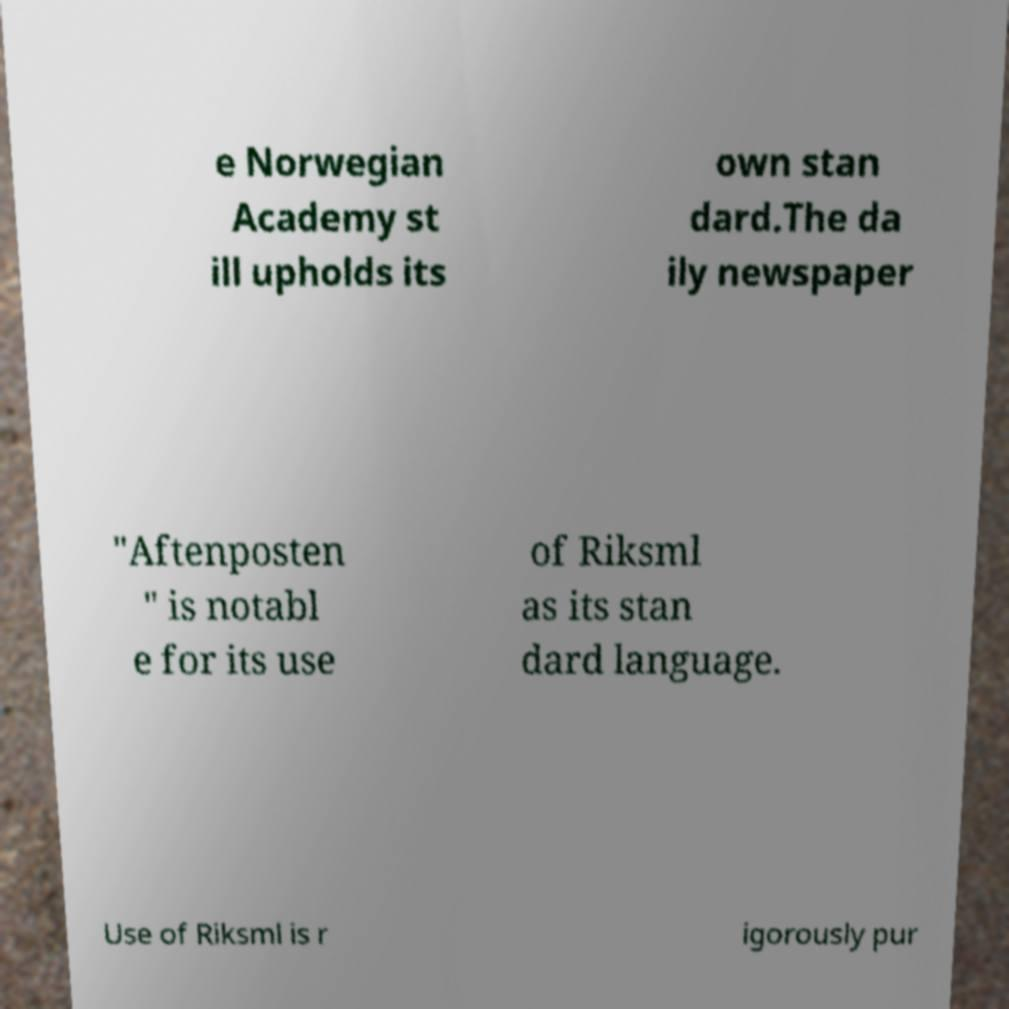Please read and relay the text visible in this image. What does it say? e Norwegian Academy st ill upholds its own stan dard.The da ily newspaper "Aftenposten " is notabl e for its use of Riksml as its stan dard language. Use of Riksml is r igorously pur 